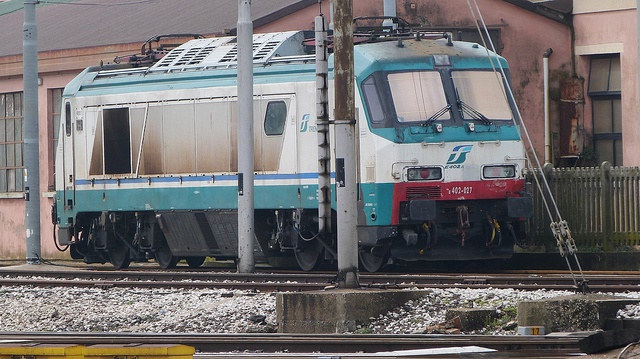Describe the objects in this image and their specific colors. I can see a train in lightgray, black, darkgray, and gray tones in this image. 